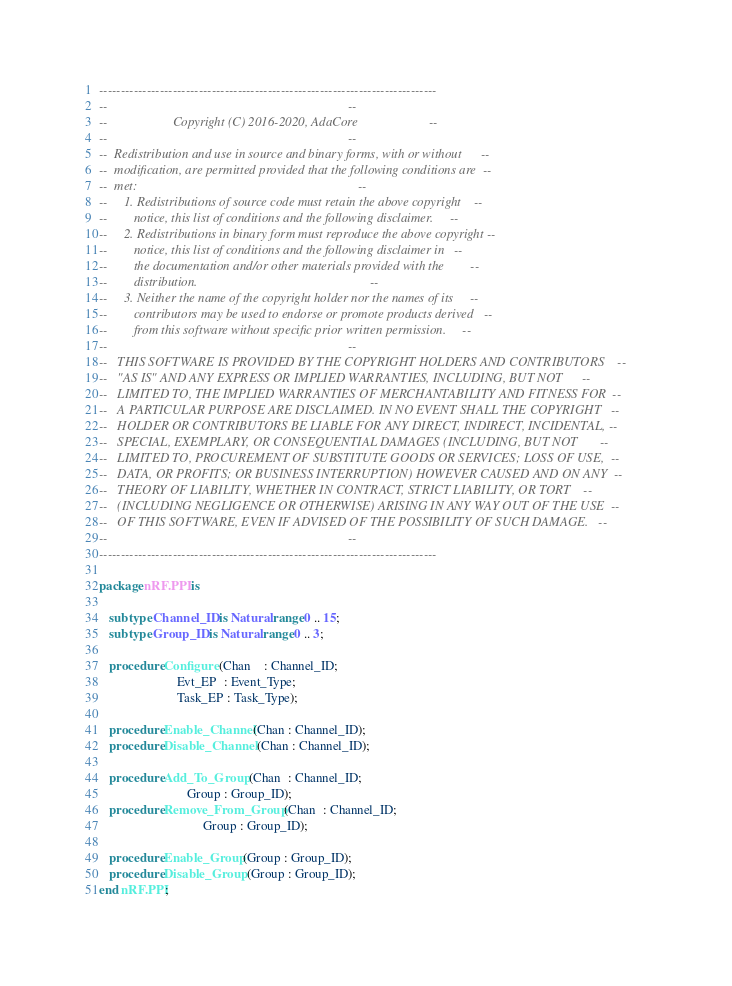Convert code to text. <code><loc_0><loc_0><loc_500><loc_500><_Ada_>------------------------------------------------------------------------------
--                                                                          --
--                    Copyright (C) 2016-2020, AdaCore                      --
--                                                                          --
--  Redistribution and use in source and binary forms, with or without      --
--  modification, are permitted provided that the following conditions are  --
--  met:                                                                    --
--     1. Redistributions of source code must retain the above copyright    --
--        notice, this list of conditions and the following disclaimer.     --
--     2. Redistributions in binary form must reproduce the above copyright --
--        notice, this list of conditions and the following disclaimer in   --
--        the documentation and/or other materials provided with the        --
--        distribution.                                                     --
--     3. Neither the name of the copyright holder nor the names of its     --
--        contributors may be used to endorse or promote products derived   --
--        from this software without specific prior written permission.     --
--                                                                          --
--   THIS SOFTWARE IS PROVIDED BY THE COPYRIGHT HOLDERS AND CONTRIBUTORS    --
--   "AS IS" AND ANY EXPRESS OR IMPLIED WARRANTIES, INCLUDING, BUT NOT      --
--   LIMITED TO, THE IMPLIED WARRANTIES OF MERCHANTABILITY AND FITNESS FOR  --
--   A PARTICULAR PURPOSE ARE DISCLAIMED. IN NO EVENT SHALL THE COPYRIGHT   --
--   HOLDER OR CONTRIBUTORS BE LIABLE FOR ANY DIRECT, INDIRECT, INCIDENTAL, --
--   SPECIAL, EXEMPLARY, OR CONSEQUENTIAL DAMAGES (INCLUDING, BUT NOT       --
--   LIMITED TO, PROCUREMENT OF SUBSTITUTE GOODS OR SERVICES; LOSS OF USE,  --
--   DATA, OR PROFITS; OR BUSINESS INTERRUPTION) HOWEVER CAUSED AND ON ANY  --
--   THEORY OF LIABILITY, WHETHER IN CONTRACT, STRICT LIABILITY, OR TORT    --
--   (INCLUDING NEGLIGENCE OR OTHERWISE) ARISING IN ANY WAY OUT OF THE USE  --
--   OF THIS SOFTWARE, EVEN IF ADVISED OF THE POSSIBILITY OF SUCH DAMAGE.   --
--                                                                          --
------------------------------------------------------------------------------

package nRF.PPI is

   subtype Channel_ID is Natural range 0 .. 15;
   subtype Group_ID is Natural range 0 .. 3;

   procedure Configure (Chan    : Channel_ID;
                        Evt_EP  : Event_Type;
                        Task_EP : Task_Type);

   procedure Enable_Channel (Chan : Channel_ID);
   procedure Disable_Channel (Chan : Channel_ID);

   procedure Add_To_Group (Chan  : Channel_ID;
                           Group : Group_ID);
   procedure Remove_From_Group (Chan  : Channel_ID;
                                Group : Group_ID);

   procedure Enable_Group (Group : Group_ID);
   procedure Disable_Group (Group : Group_ID);
end nRF.PPI;
</code> 